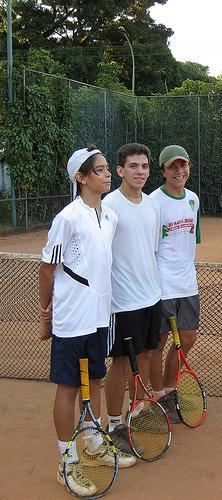Pick an object in the image and briefly describe its color and location relative to the main subjects. There is a light pole with a grayish color, located slightly above and behind the tennis players. Identify the primary activity taking place in the image with a short sentence. Three young male tennis players are standing together on a tennis court. Write a brief advertisement for a line of tennis rackets featuring the image. Introducing our new range of tennis rackets! Featured by smiling young players on the court, our rackets come in vibrant colors with comfortable grips. Make every match unforgettable with our high-performance rackets! Describe the type of tennis court the boys are standing on and mention any visible shoe in the image. The boys are on a clay tennis court. You can see a white gym shoe and a black gym shoe in the image. Answer this riddle about the image: What is surrounded by three friends, three tennis rackets, and a mesh net? A clay tennis court. What can be found in the background of the image besides the tennis court and its net? There's a forest behind a fence and ivy on the fence. Mention three key features in the scene; one about the main subjects, one about their attire, and one about where they're standing. They are three young male tennis players; they are wearing white shirts and athletic shoes; and they are on a clay tennis court. Imagine you're explaining the image to a visually impaired person. Describe the appearance of the three boys. There are three smiling, young male tennis players; one has a green hat, another has a white hat facing forward, and the third one has a white hat facing backward. They are all wearing white shirts and shorts. What are the colors of the boy's hats in the image? Green, white, and a white one facing backwards. Identify and describe the types of tennis rackets seen in the image. There are three tennis rackets: one with a red frame and a yellow handle, another with a black handle, and the third one has yellow and blue details. 